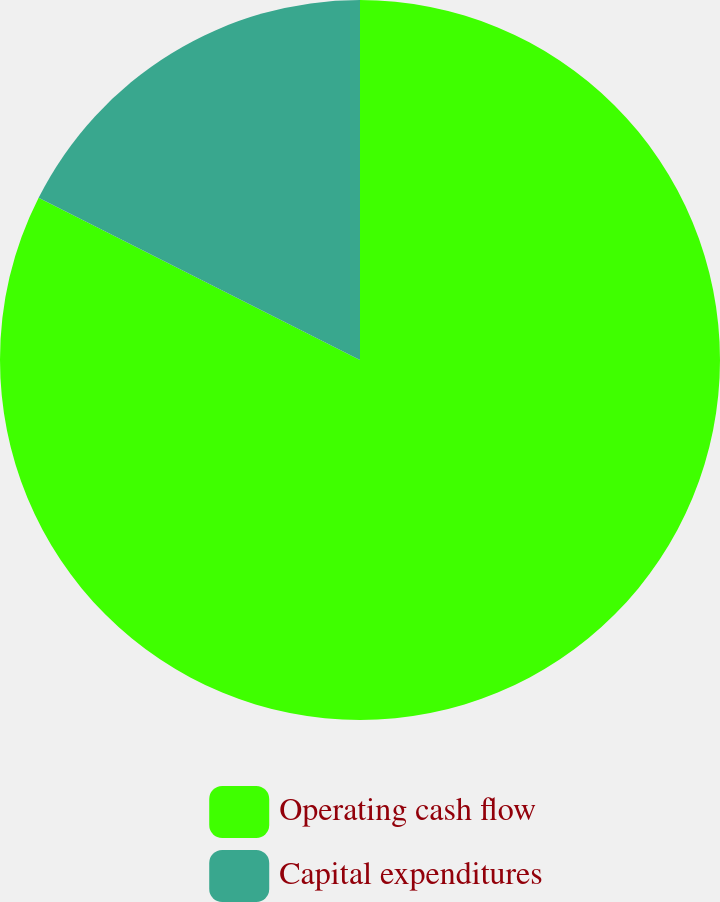Convert chart. <chart><loc_0><loc_0><loc_500><loc_500><pie_chart><fcel>Operating cash flow<fcel>Capital expenditures<nl><fcel>82.44%<fcel>17.56%<nl></chart> 